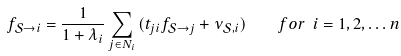Convert formula to latex. <formula><loc_0><loc_0><loc_500><loc_500>f _ { \mathcal { S } \rightarrow i } = \frac { 1 } { 1 + \lambda _ { i } } \sum _ { j \in N _ { i } } { ( t _ { j i } f _ { \mathcal { S } \rightarrow j } + \nu _ { \mathcal { S } , i } ) } \quad f o r \ i = 1 , 2 , \dots n</formula> 